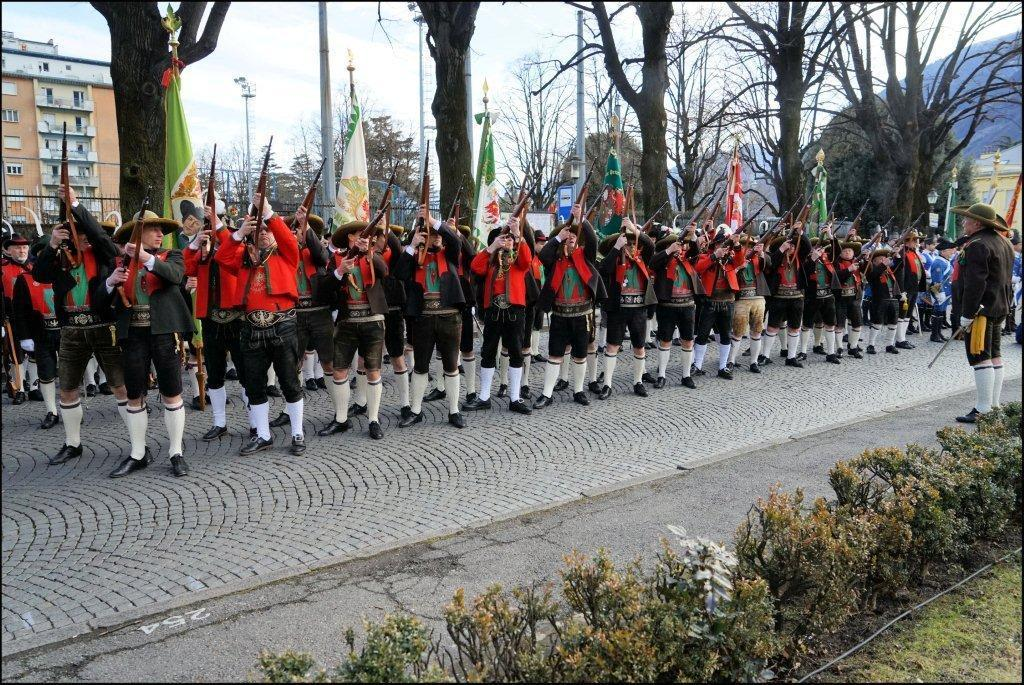What are the people in the image holding? The people in the image are holding guns in their hands. What can be seen in the background of the image? In the background of the image, there are flags, trees, poles, buildings, and the sky. Where are the plants located in the image? The plants are in the bottom right corner of the image. Is there any blood visible on the ground in the image? There is no blood visible on the ground in the image. What type of alley can be seen in the image? There is no alley present in the image. 